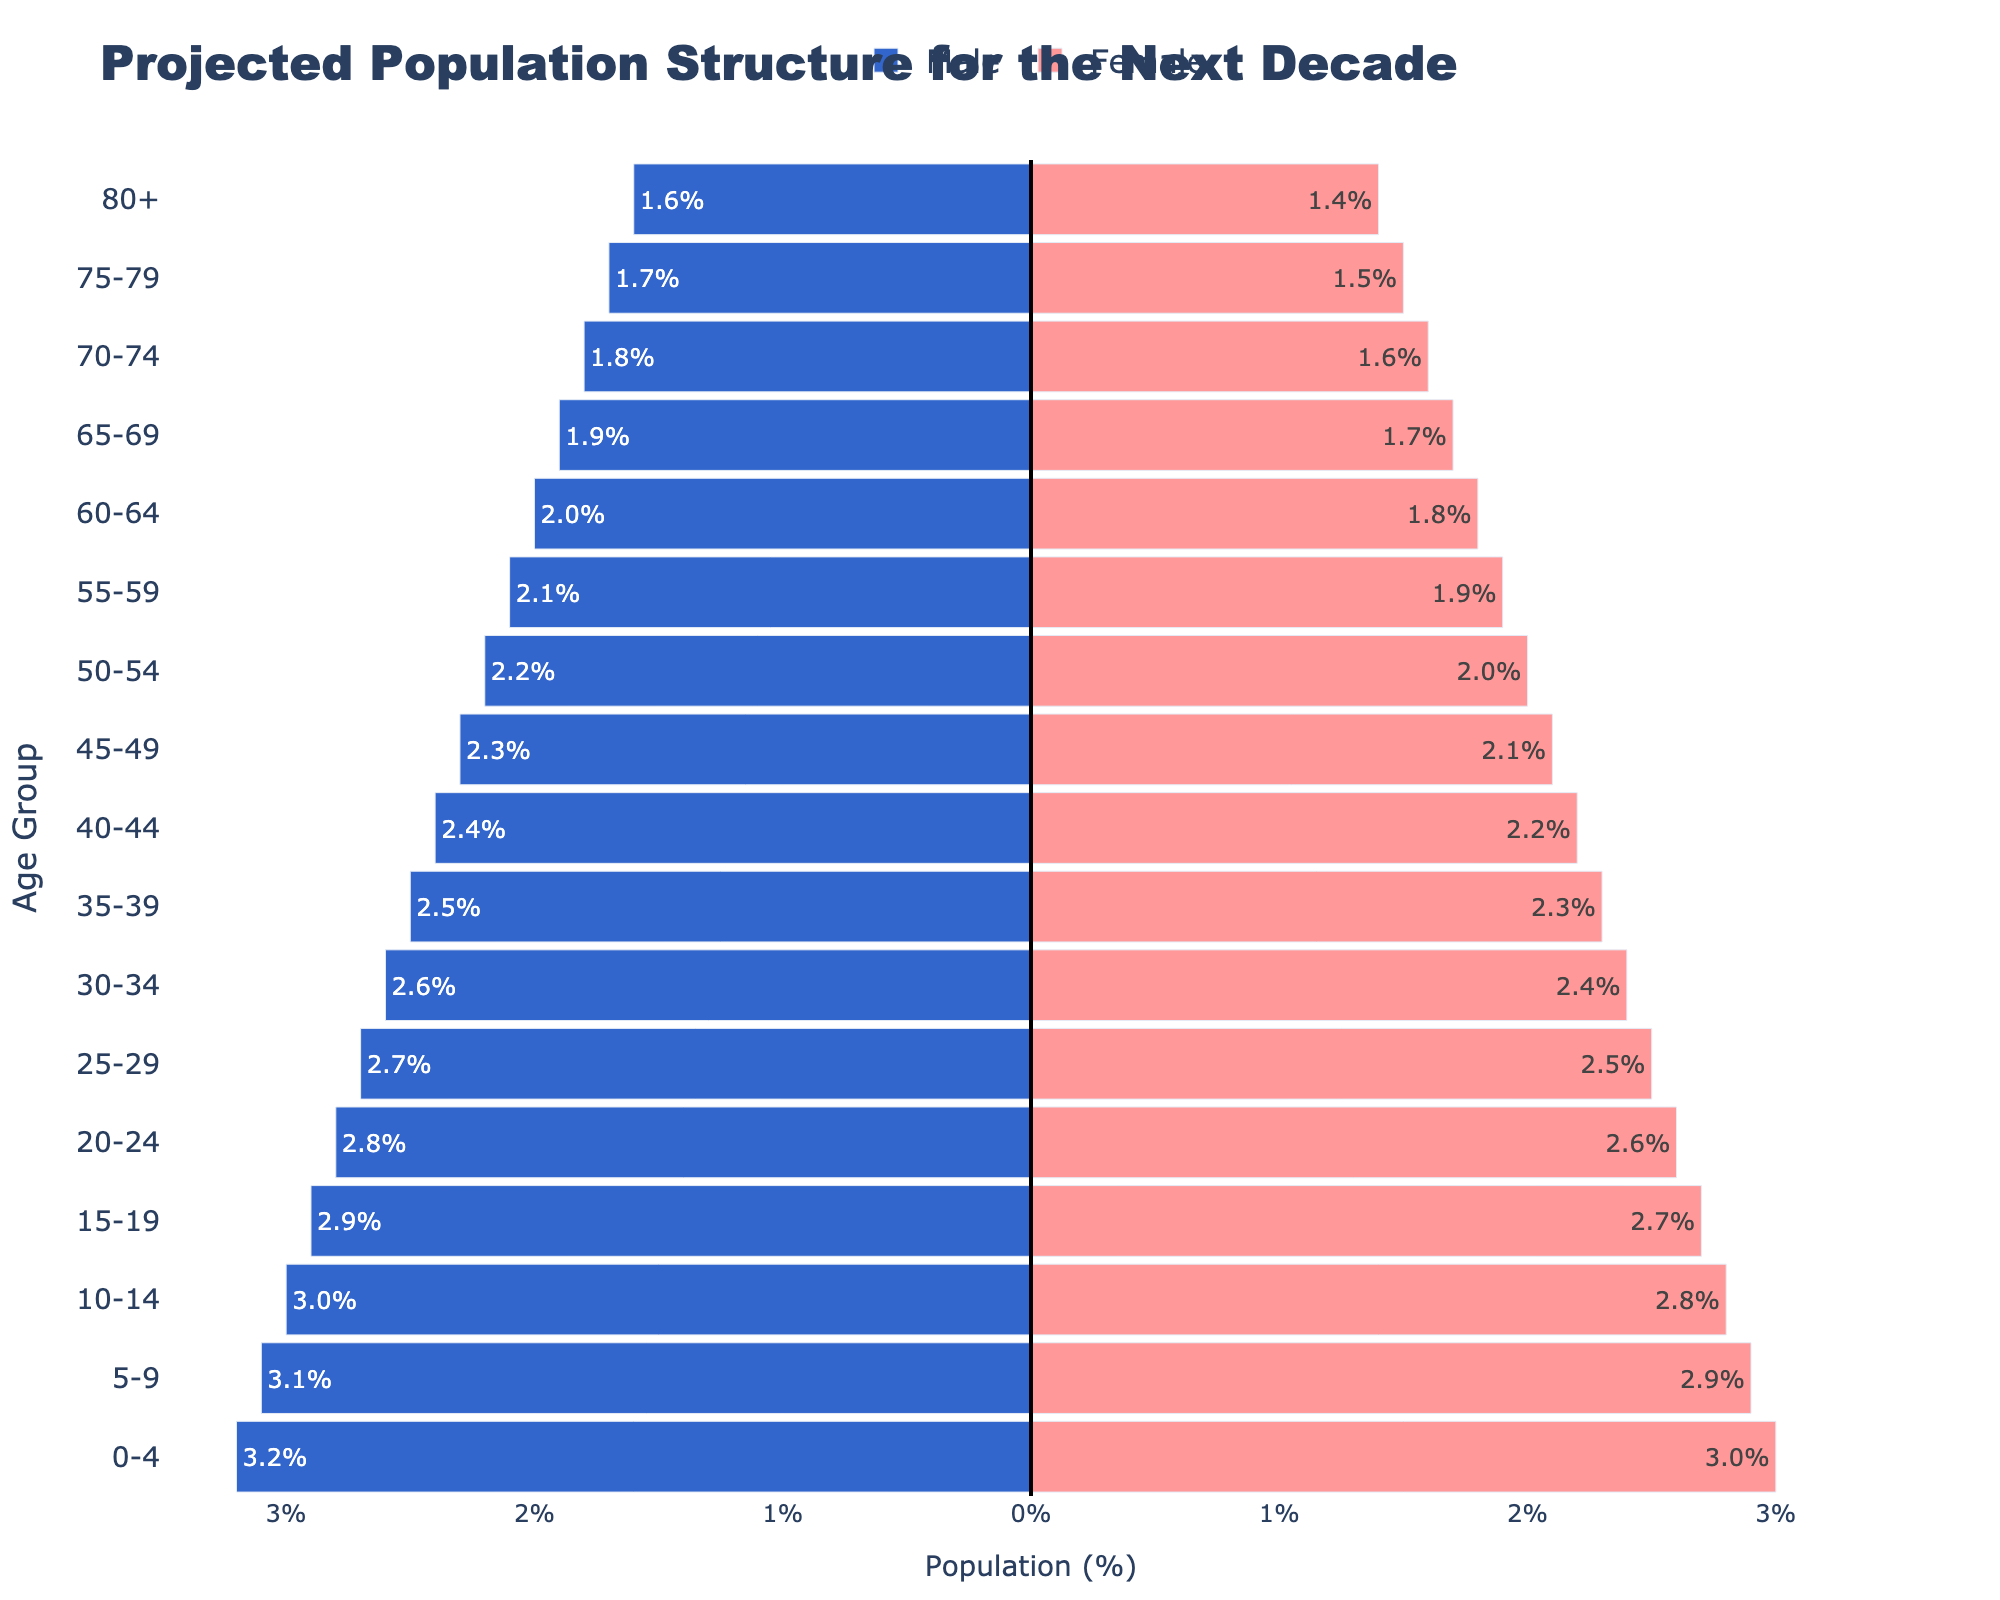What is the title of the figure? The title of the figure is prominently displayed at the top and reads "Projected Population Structure for the Next Decade."
Answer: Projected Population Structure for the Next Decade What percentage of the population is male in the 0-4 age group? The bar corresponding to the 0-4 age group on the left side of the pyramid shows the male percentage with negative values, indicating 3.2%.
Answer: 3.2% How does the population percentage of females aged 20-24 compare to that of females aged 60-64? The population percentage of females aged 20-24 is represented by the bar on the right side of the pyramid with a value of 2.6%, and for females aged 60-64, it is 1.8%. Thus, the 20-24 age group is higher by 0.8 percentage points.
Answer: 2.6% for 20-24, 1.8% for 60-64 Which gender has a higher percentage in the 75-79 age group, and by how much? In the 75-79 age group, males have a percentage of 1.7%, and females have a percentage of 1.5%. Males have a higher percentage by 0.2%.
Answer: Males by 0.2% What is the total percentage of the population in the 55-59 age group, combining both males and females? The population percentage of males in the 55-59 age group is 2.1%, and for females, it is 1.9%. Adding these values gives a total of 4.0%.
Answer: 4.0% What is the general trend in population percentage as age increases? As age increases, both male and female population percentages exhibit a decreasing trend, indicating that the population pyramids narrow towards the top.
Answer: Decreasing Between which two age groups does the largest drop in male population percentage occur? The male percentage decreases from 3.2% in the 0-4 age group to 1.6% in the 80+ age group. The largest drop occurs between the 20-24 (2.8%) and 25-29 (2.7%) age groups, showing a drop of 0.1%.
Answer: 20-24 and 25-29 What age group has the smallest difference in population percentage between males and females? The smallest difference in population percentage between males and females occurs in the 80+ age group, where the difference is 0.2% (1.6% males and 1.4% females).
Answer: 80+ 